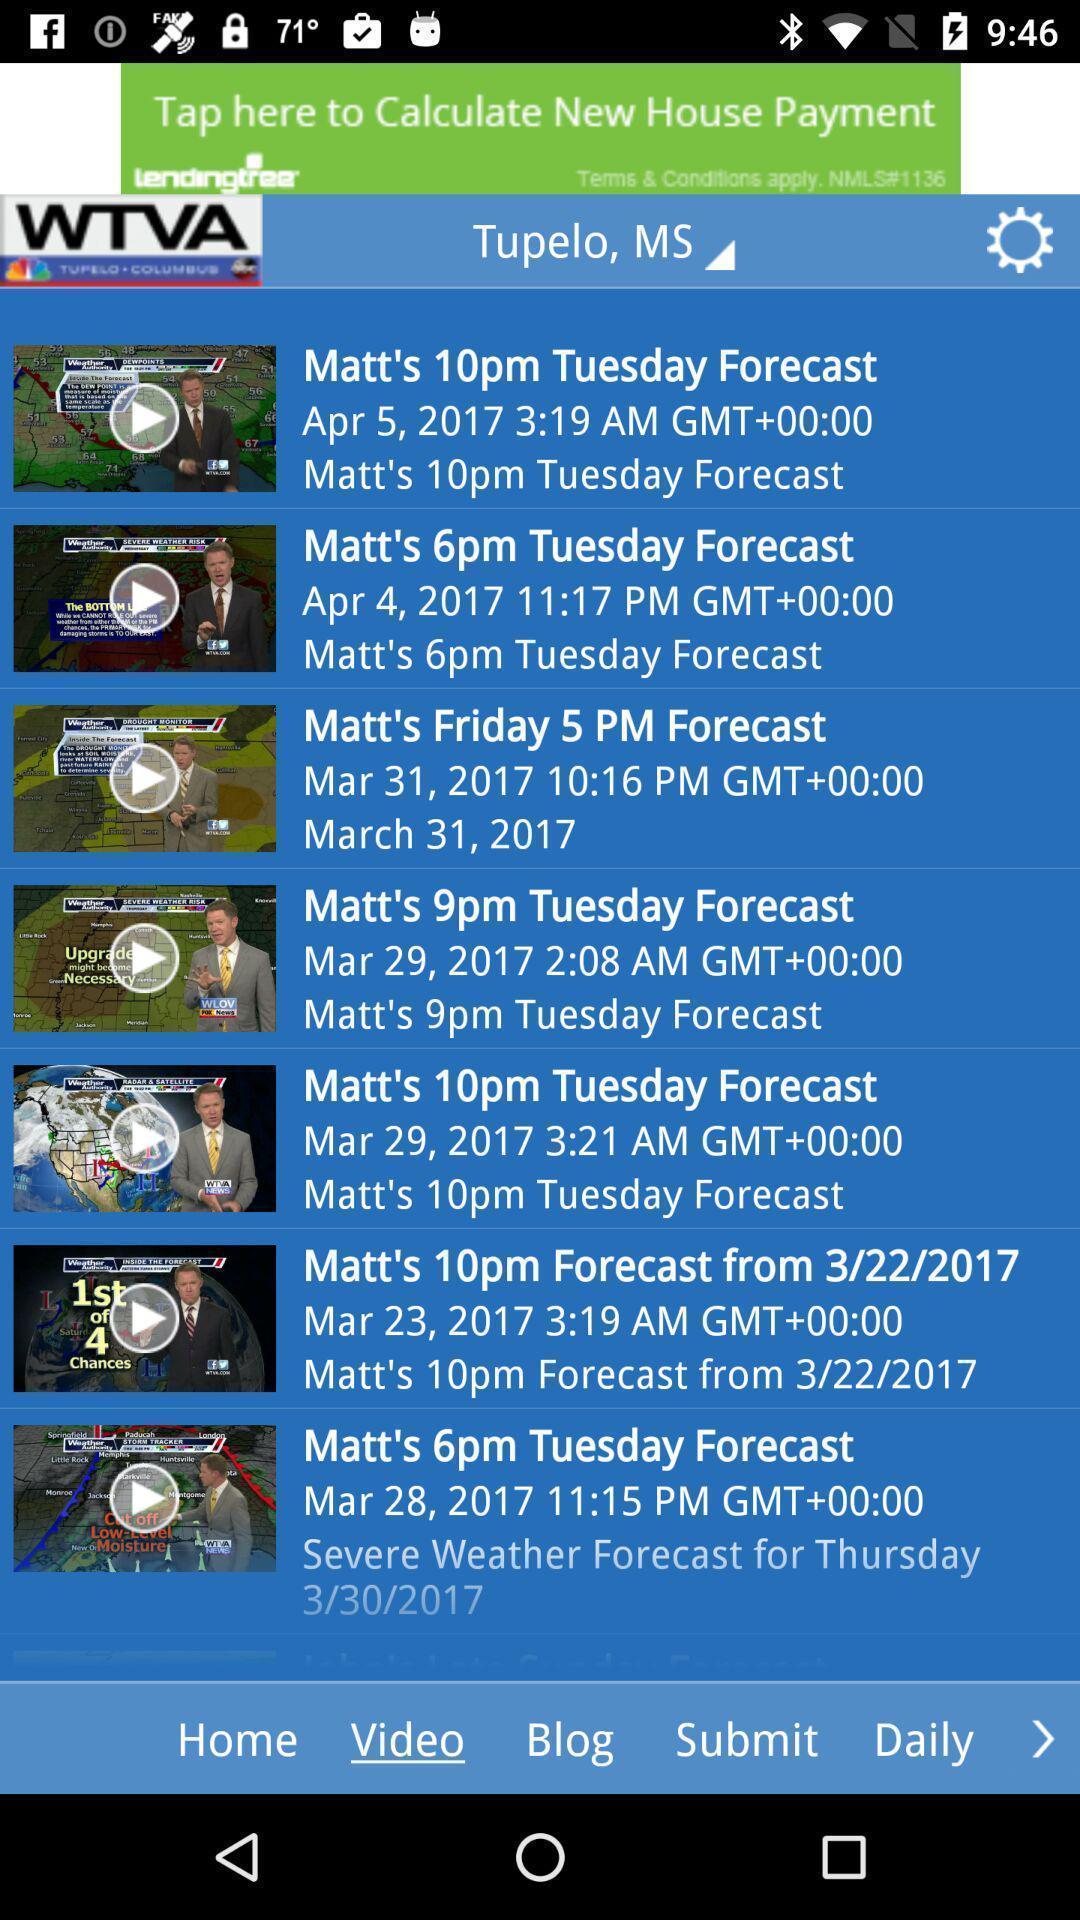Explain the elements present in this screenshot. Page displaying forecast details of an weather application. 